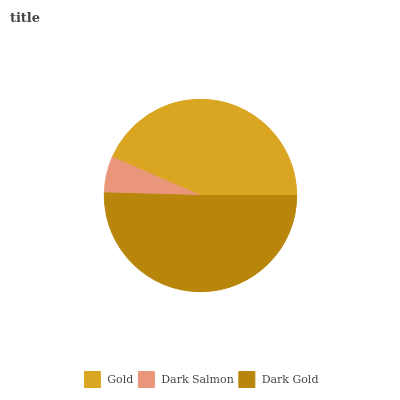Is Dark Salmon the minimum?
Answer yes or no. Yes. Is Dark Gold the maximum?
Answer yes or no. Yes. Is Dark Gold the minimum?
Answer yes or no. No. Is Dark Salmon the maximum?
Answer yes or no. No. Is Dark Gold greater than Dark Salmon?
Answer yes or no. Yes. Is Dark Salmon less than Dark Gold?
Answer yes or no. Yes. Is Dark Salmon greater than Dark Gold?
Answer yes or no. No. Is Dark Gold less than Dark Salmon?
Answer yes or no. No. Is Gold the high median?
Answer yes or no. Yes. Is Gold the low median?
Answer yes or no. Yes. Is Dark Salmon the high median?
Answer yes or no. No. Is Dark Gold the low median?
Answer yes or no. No. 